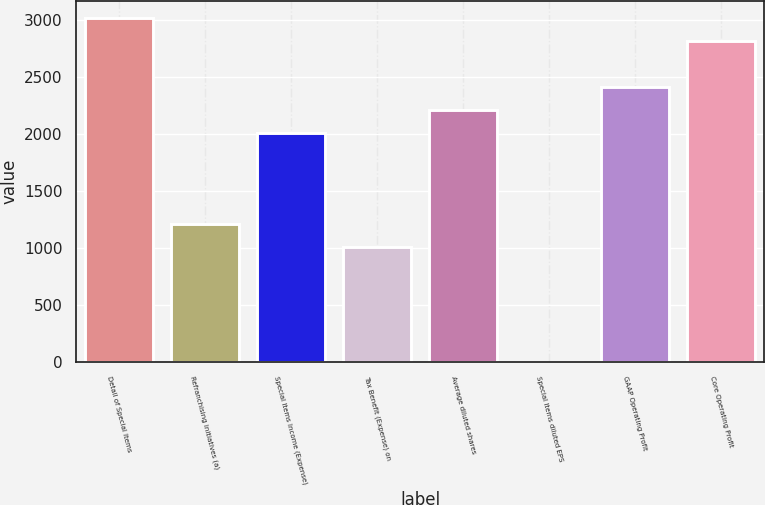<chart> <loc_0><loc_0><loc_500><loc_500><bar_chart><fcel>Detail of Special Items<fcel>Refranchising initiatives (a)<fcel>Special Items Income (Expense)<fcel>Tax Benefit (Expense) on<fcel>Average diluted shares<fcel>Special Items diluted EPS<fcel>GAAP Operating Profit<fcel>Core Operating Profit<nl><fcel>3022.42<fcel>1209.1<fcel>2015.02<fcel>1007.62<fcel>2216.5<fcel>0.22<fcel>2417.98<fcel>2820.94<nl></chart> 